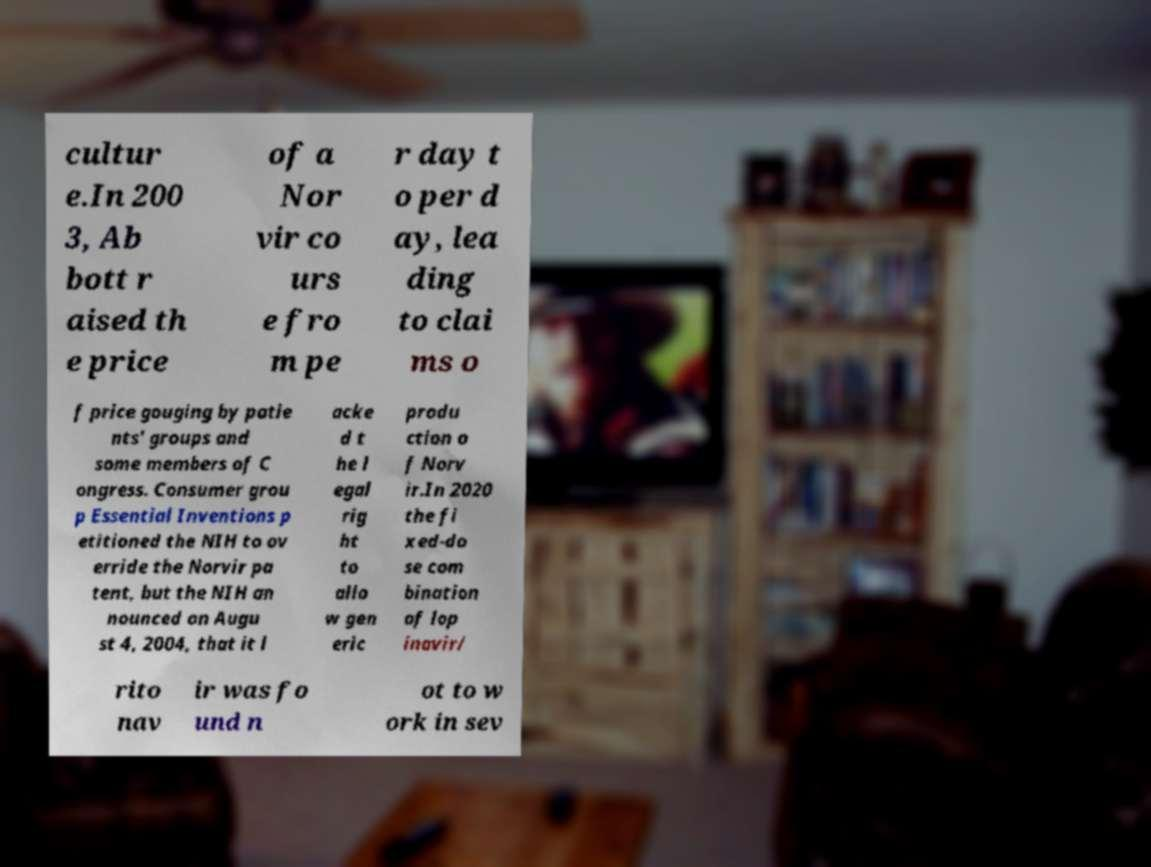Could you assist in decoding the text presented in this image and type it out clearly? cultur e.In 200 3, Ab bott r aised th e price of a Nor vir co urs e fro m pe r day t o per d ay, lea ding to clai ms o f price gouging by patie nts' groups and some members of C ongress. Consumer grou p Essential Inventions p etitioned the NIH to ov erride the Norvir pa tent, but the NIH an nounced on Augu st 4, 2004, that it l acke d t he l egal rig ht to allo w gen eric produ ction o f Norv ir.In 2020 the fi xed-do se com bination of lop inavir/ rito nav ir was fo und n ot to w ork in sev 